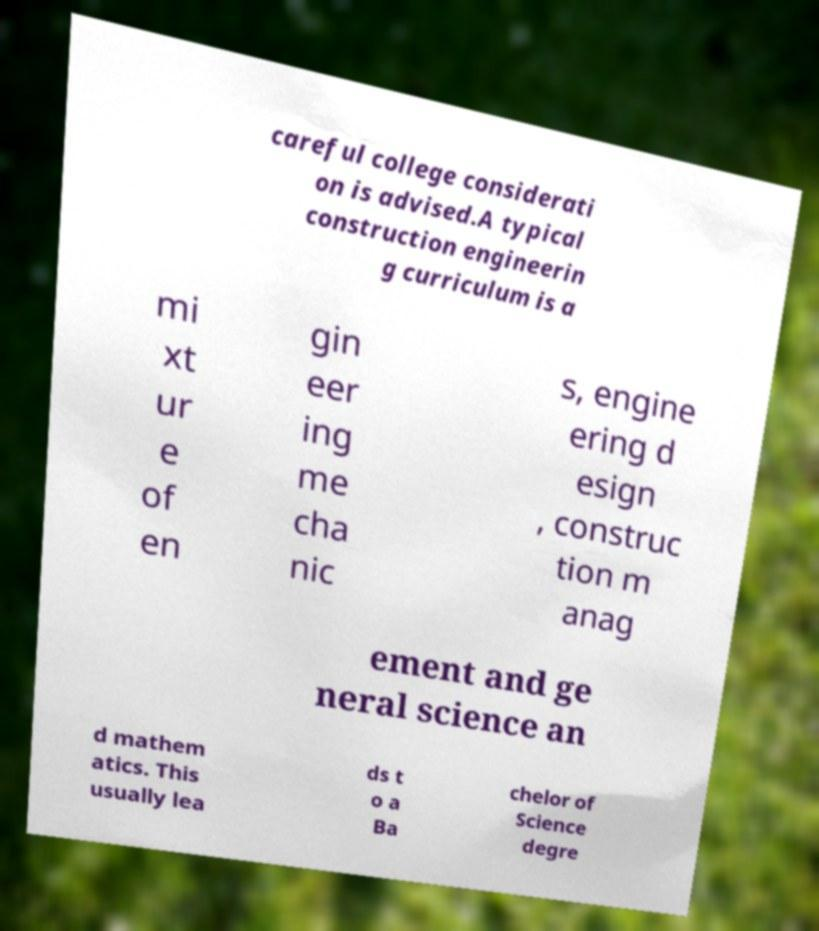Could you extract and type out the text from this image? careful college considerati on is advised.A typical construction engineerin g curriculum is a mi xt ur e of en gin eer ing me cha nic s, engine ering d esign , construc tion m anag ement and ge neral science an d mathem atics. This usually lea ds t o a Ba chelor of Science degre 